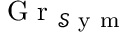<formula> <loc_0><loc_0><loc_500><loc_500>G r _ { \mathcal { S } y m }</formula> 